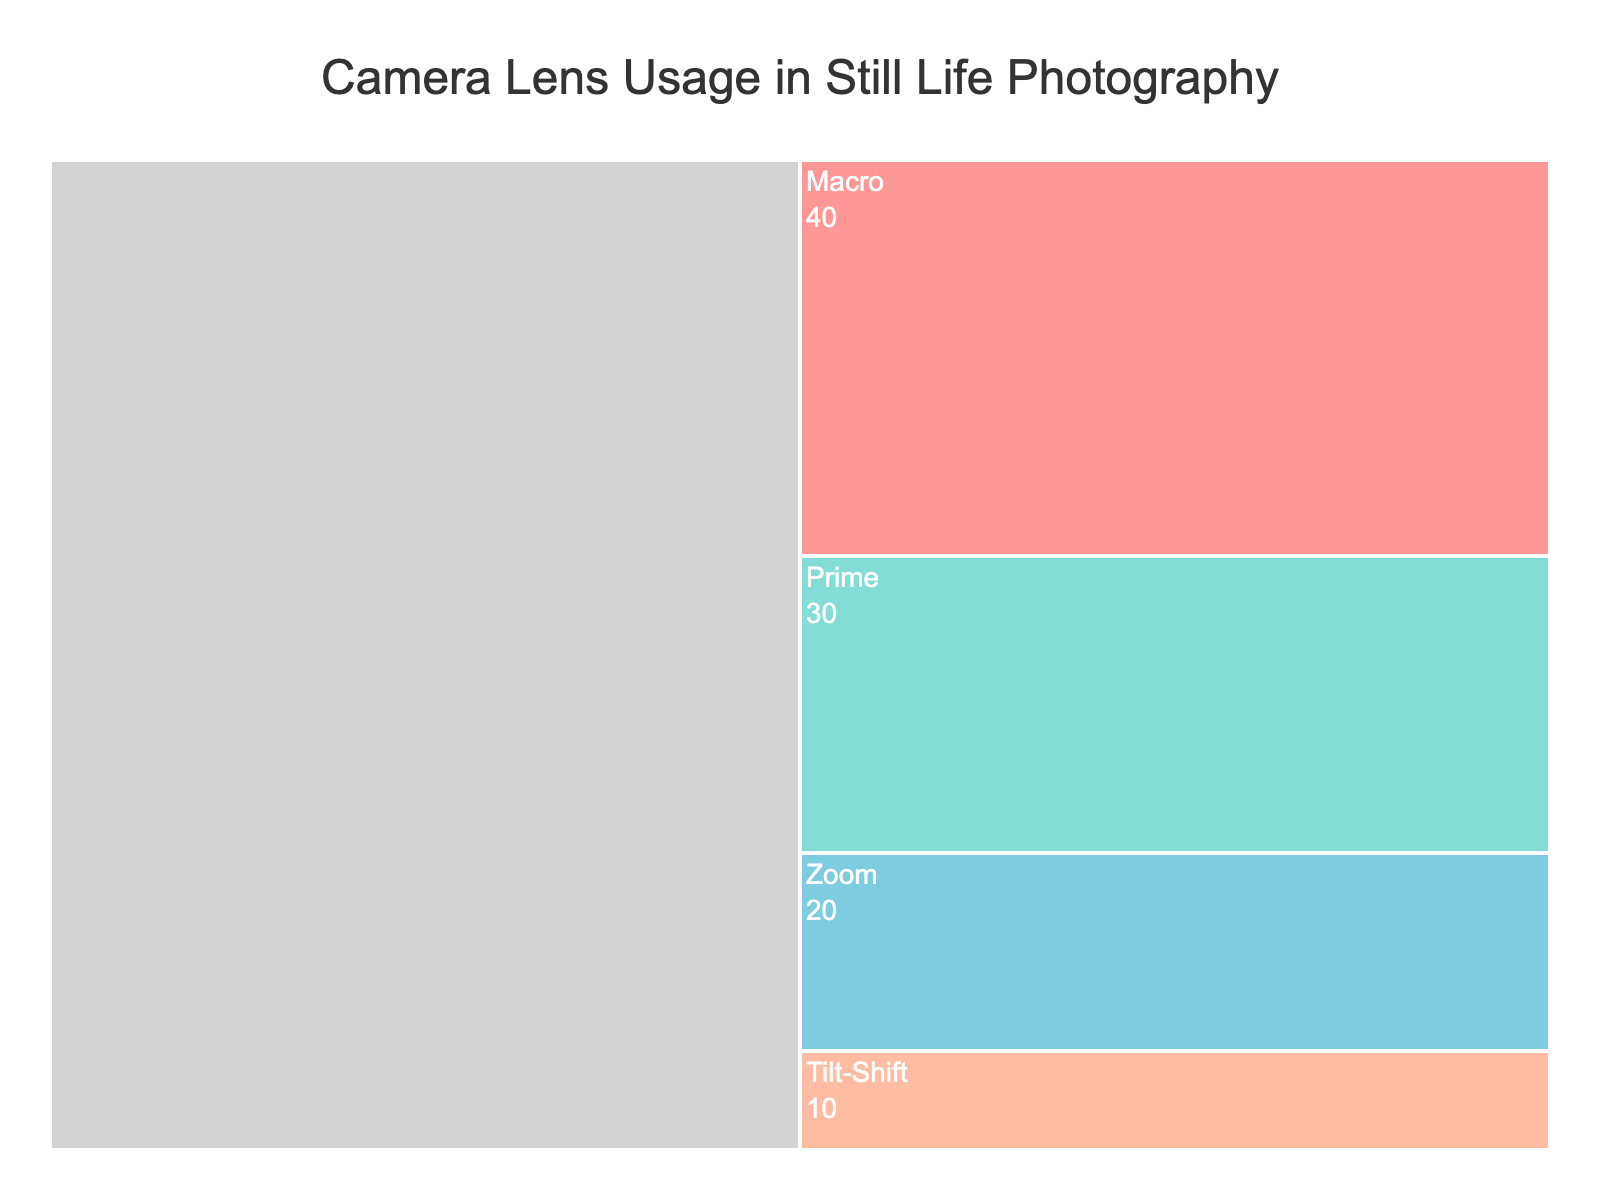What is the title of the figure? The title is displayed at the top of the chart. It reads "Camera Lens Usage in Still Life Photography".
Answer: Camera Lens Usage in Still Life Photography How many different types of camera lenses are shown in the figure? The chart displays labels for each camera lens type used in still life photography. Counting them, we have Macro, Prime, Zoom, and Tilt-Shift, totaling four types.
Answer: Four Which camera lens type is used the most frequently in still life photography? In the chart, the lens with the highest value is the Macro lens, with a usage frequency of 40.
Answer: Macro How much more frequently is the Macro lens used compared to the Prime lens? The Macro lens has a usage frequency of 40, and the Prime lens has 30. Subtracting these values (40 - 30) gives the difference.
Answer: 10 What percentage of the total usage does the Zoom lens account for? First, sum all usage frequencies: 40 (Macro) + 30 (Prime) + 20 (Zoom) + 10 (Tilt-Shift) = 100. The Zoom lens frequency is 20. The percentage is (20/100) * 100 = 20%.
Answer: 20% Which lens type has the least usage frequency? The Tilt-Shift lens appears in the chart with the smallest value, which is 10, indicating it has the least usage.
Answer: Tilt-Shift Compare the combined usage frequency of Prime and Zoom lenses to the usage frequency of the Macro lens. Is it higher or lower? Combined usage for Prime and Zoom lenses is 30 (Prime) + 20 (Zoom) = 50. The Macro lens has a frequency of 40. Since 50 is greater than 40, the combined usage is higher.
Answer: Higher If still life photography usage shifts 10 units from Macro to Tilt-Shift, will Macro still be the most used lens? Originally, Macro has 40, and Tilt-Shift has 10. Shifting 10 units makes Macro 30 and Tilt-Shift 20. The Prime lens has 30, thus Macro will not be the most used lens anymore; it will tie with Prime.
Answer: No What is the average usage frequency of all the camera lens types? Sum of all usage frequencies is 100, and there are 4 lens types. The average is calculated as 100 / 4.
Answer: 25 